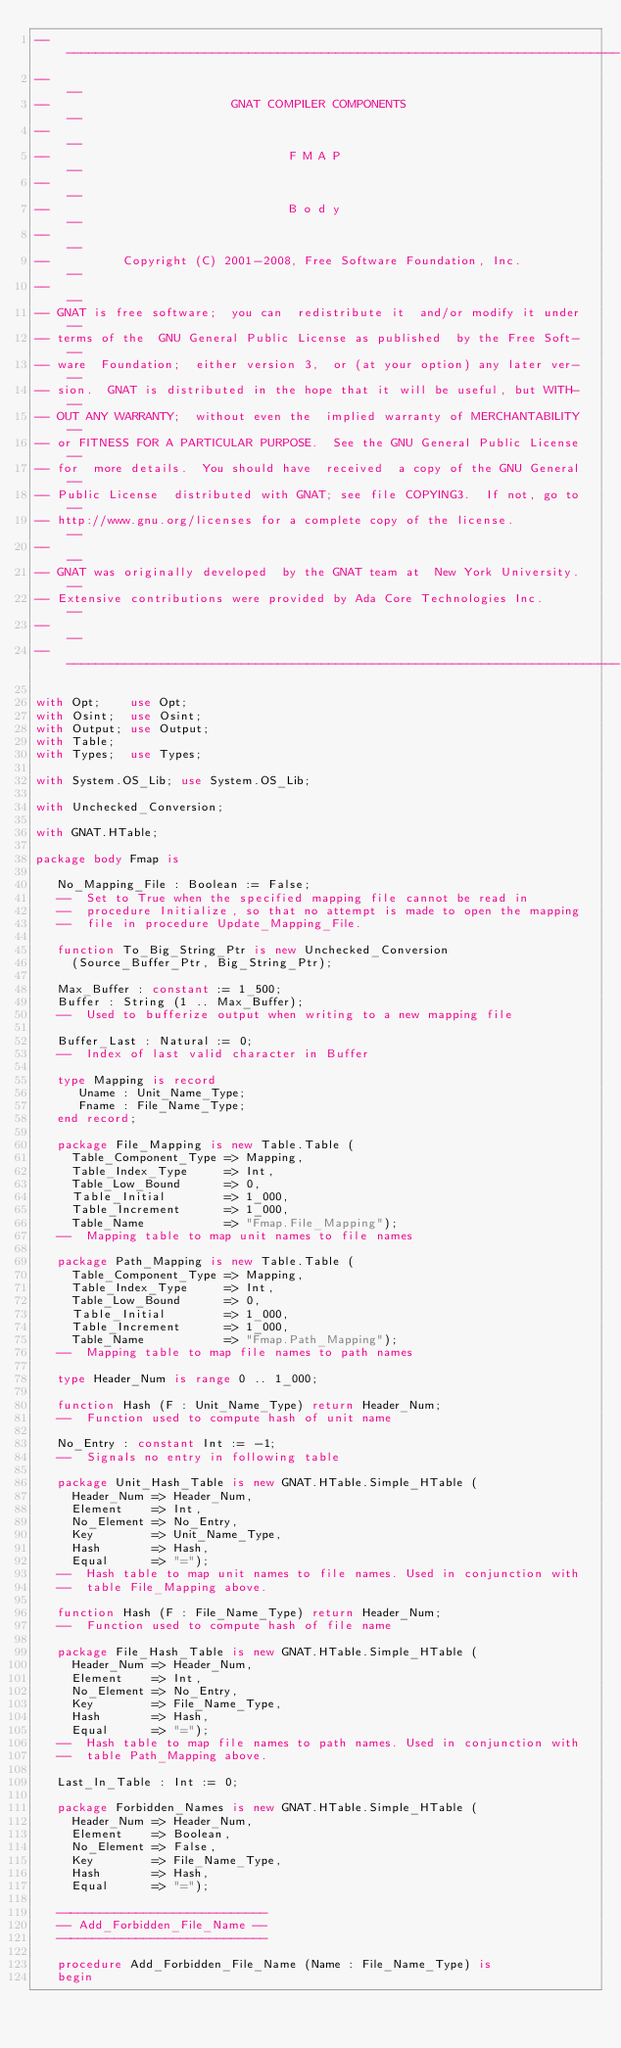Convert code to text. <code><loc_0><loc_0><loc_500><loc_500><_Ada_>------------------------------------------------------------------------------
--                                                                          --
--                         GNAT COMPILER COMPONENTS                         --
--                                                                          --
--                                 F M A P                                  --
--                                                                          --
--                                 B o d y                                  --
--                                                                          --
--          Copyright (C) 2001-2008, Free Software Foundation, Inc.         --
--                                                                          --
-- GNAT is free software;  you can  redistribute it  and/or modify it under --
-- terms of the  GNU General Public License as published  by the Free Soft- --
-- ware  Foundation;  either version 3,  or (at your option) any later ver- --
-- sion.  GNAT is distributed in the hope that it will be useful, but WITH- --
-- OUT ANY WARRANTY;  without even the  implied warranty of MERCHANTABILITY --
-- or FITNESS FOR A PARTICULAR PURPOSE.  See the GNU General Public License --
-- for  more details.  You should have  received  a copy of the GNU General --
-- Public License  distributed with GNAT; see file COPYING3.  If not, go to --
-- http://www.gnu.org/licenses for a complete copy of the license.          --
--                                                                          --
-- GNAT was originally developed  by the GNAT team at  New York University. --
-- Extensive contributions were provided by Ada Core Technologies Inc.      --
--                                                                          --
------------------------------------------------------------------------------

with Opt;    use Opt;
with Osint;  use Osint;
with Output; use Output;
with Table;
with Types;  use Types;

with System.OS_Lib; use System.OS_Lib;

with Unchecked_Conversion;

with GNAT.HTable;

package body Fmap is

   No_Mapping_File : Boolean := False;
   --  Set to True when the specified mapping file cannot be read in
   --  procedure Initialize, so that no attempt is made to open the mapping
   --  file in procedure Update_Mapping_File.

   function To_Big_String_Ptr is new Unchecked_Conversion
     (Source_Buffer_Ptr, Big_String_Ptr);

   Max_Buffer : constant := 1_500;
   Buffer : String (1 .. Max_Buffer);
   --  Used to bufferize output when writing to a new mapping file

   Buffer_Last : Natural := 0;
   --  Index of last valid character in Buffer

   type Mapping is record
      Uname : Unit_Name_Type;
      Fname : File_Name_Type;
   end record;

   package File_Mapping is new Table.Table (
     Table_Component_Type => Mapping,
     Table_Index_Type     => Int,
     Table_Low_Bound      => 0,
     Table_Initial        => 1_000,
     Table_Increment      => 1_000,
     Table_Name           => "Fmap.File_Mapping");
   --  Mapping table to map unit names to file names

   package Path_Mapping is new Table.Table (
     Table_Component_Type => Mapping,
     Table_Index_Type     => Int,
     Table_Low_Bound      => 0,
     Table_Initial        => 1_000,
     Table_Increment      => 1_000,
     Table_Name           => "Fmap.Path_Mapping");
   --  Mapping table to map file names to path names

   type Header_Num is range 0 .. 1_000;

   function Hash (F : Unit_Name_Type) return Header_Num;
   --  Function used to compute hash of unit name

   No_Entry : constant Int := -1;
   --  Signals no entry in following table

   package Unit_Hash_Table is new GNAT.HTable.Simple_HTable (
     Header_Num => Header_Num,
     Element    => Int,
     No_Element => No_Entry,
     Key        => Unit_Name_Type,
     Hash       => Hash,
     Equal      => "=");
   --  Hash table to map unit names to file names. Used in conjunction with
   --  table File_Mapping above.

   function Hash (F : File_Name_Type) return Header_Num;
   --  Function used to compute hash of file name

   package File_Hash_Table is new GNAT.HTable.Simple_HTable (
     Header_Num => Header_Num,
     Element    => Int,
     No_Element => No_Entry,
     Key        => File_Name_Type,
     Hash       => Hash,
     Equal      => "=");
   --  Hash table to map file names to path names. Used in conjunction with
   --  table Path_Mapping above.

   Last_In_Table : Int := 0;

   package Forbidden_Names is new GNAT.HTable.Simple_HTable (
     Header_Num => Header_Num,
     Element    => Boolean,
     No_Element => False,
     Key        => File_Name_Type,
     Hash       => Hash,
     Equal      => "=");

   -----------------------------
   -- Add_Forbidden_File_Name --
   -----------------------------

   procedure Add_Forbidden_File_Name (Name : File_Name_Type) is
   begin</code> 